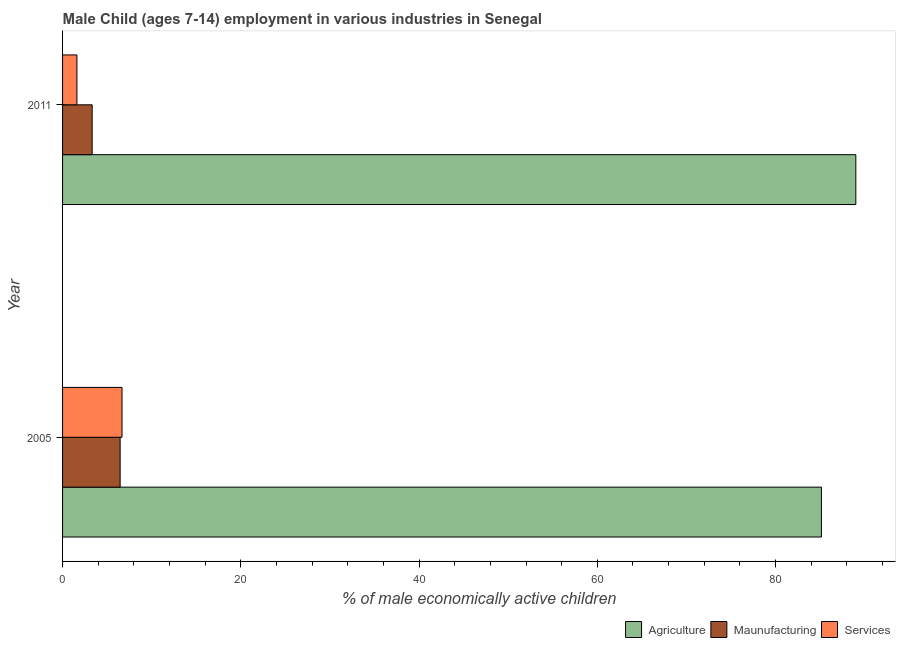What is the percentage of economically active children in services in 2011?
Make the answer very short. 1.61. Across all years, what is the maximum percentage of economically active children in manufacturing?
Offer a terse response. 6.46. Across all years, what is the minimum percentage of economically active children in manufacturing?
Provide a short and direct response. 3.32. In which year was the percentage of economically active children in services minimum?
Offer a terse response. 2011. What is the total percentage of economically active children in manufacturing in the graph?
Keep it short and to the point. 9.78. What is the difference between the percentage of economically active children in agriculture in 2005 and that in 2011?
Ensure brevity in your answer.  -3.86. What is the difference between the percentage of economically active children in agriculture in 2005 and the percentage of economically active children in services in 2011?
Offer a very short reply. 83.54. What is the average percentage of economically active children in manufacturing per year?
Offer a terse response. 4.89. In the year 2005, what is the difference between the percentage of economically active children in agriculture and percentage of economically active children in manufacturing?
Ensure brevity in your answer.  78.69. What is the ratio of the percentage of economically active children in manufacturing in 2005 to that in 2011?
Ensure brevity in your answer.  1.95. Is the percentage of economically active children in services in 2005 less than that in 2011?
Offer a very short reply. No. Is the difference between the percentage of economically active children in services in 2005 and 2011 greater than the difference between the percentage of economically active children in agriculture in 2005 and 2011?
Make the answer very short. Yes. What does the 3rd bar from the top in 2011 represents?
Your answer should be compact. Agriculture. What does the 3rd bar from the bottom in 2005 represents?
Your answer should be very brief. Services. Is it the case that in every year, the sum of the percentage of economically active children in agriculture and percentage of economically active children in manufacturing is greater than the percentage of economically active children in services?
Your response must be concise. Yes. Are all the bars in the graph horizontal?
Keep it short and to the point. Yes. How many years are there in the graph?
Offer a terse response. 2. Are the values on the major ticks of X-axis written in scientific E-notation?
Provide a short and direct response. No. Does the graph contain any zero values?
Your answer should be compact. No. Does the graph contain grids?
Ensure brevity in your answer.  No. How many legend labels are there?
Ensure brevity in your answer.  3. How are the legend labels stacked?
Your response must be concise. Horizontal. What is the title of the graph?
Your response must be concise. Male Child (ages 7-14) employment in various industries in Senegal. Does "Ages 0-14" appear as one of the legend labels in the graph?
Your answer should be compact. No. What is the label or title of the X-axis?
Offer a very short reply. % of male economically active children. What is the label or title of the Y-axis?
Keep it short and to the point. Year. What is the % of male economically active children in Agriculture in 2005?
Offer a terse response. 85.15. What is the % of male economically active children of Maunufacturing in 2005?
Keep it short and to the point. 6.46. What is the % of male economically active children in Services in 2005?
Offer a terse response. 6.67. What is the % of male economically active children in Agriculture in 2011?
Your answer should be compact. 89.01. What is the % of male economically active children in Maunufacturing in 2011?
Your answer should be compact. 3.32. What is the % of male economically active children of Services in 2011?
Make the answer very short. 1.61. Across all years, what is the maximum % of male economically active children in Agriculture?
Ensure brevity in your answer.  89.01. Across all years, what is the maximum % of male economically active children of Maunufacturing?
Give a very brief answer. 6.46. Across all years, what is the maximum % of male economically active children of Services?
Your answer should be very brief. 6.67. Across all years, what is the minimum % of male economically active children in Agriculture?
Provide a short and direct response. 85.15. Across all years, what is the minimum % of male economically active children in Maunufacturing?
Your response must be concise. 3.32. Across all years, what is the minimum % of male economically active children in Services?
Give a very brief answer. 1.61. What is the total % of male economically active children in Agriculture in the graph?
Your answer should be compact. 174.16. What is the total % of male economically active children in Maunufacturing in the graph?
Offer a very short reply. 9.78. What is the total % of male economically active children of Services in the graph?
Provide a succinct answer. 8.28. What is the difference between the % of male economically active children in Agriculture in 2005 and that in 2011?
Provide a succinct answer. -3.86. What is the difference between the % of male economically active children in Maunufacturing in 2005 and that in 2011?
Provide a succinct answer. 3.14. What is the difference between the % of male economically active children in Services in 2005 and that in 2011?
Keep it short and to the point. 5.06. What is the difference between the % of male economically active children of Agriculture in 2005 and the % of male economically active children of Maunufacturing in 2011?
Your answer should be compact. 81.83. What is the difference between the % of male economically active children of Agriculture in 2005 and the % of male economically active children of Services in 2011?
Ensure brevity in your answer.  83.54. What is the difference between the % of male economically active children of Maunufacturing in 2005 and the % of male economically active children of Services in 2011?
Provide a short and direct response. 4.85. What is the average % of male economically active children of Agriculture per year?
Offer a terse response. 87.08. What is the average % of male economically active children of Maunufacturing per year?
Provide a succinct answer. 4.89. What is the average % of male economically active children in Services per year?
Make the answer very short. 4.14. In the year 2005, what is the difference between the % of male economically active children of Agriculture and % of male economically active children of Maunufacturing?
Your answer should be very brief. 78.69. In the year 2005, what is the difference between the % of male economically active children in Agriculture and % of male economically active children in Services?
Your response must be concise. 78.48. In the year 2005, what is the difference between the % of male economically active children in Maunufacturing and % of male economically active children in Services?
Ensure brevity in your answer.  -0.21. In the year 2011, what is the difference between the % of male economically active children of Agriculture and % of male economically active children of Maunufacturing?
Ensure brevity in your answer.  85.69. In the year 2011, what is the difference between the % of male economically active children of Agriculture and % of male economically active children of Services?
Your answer should be compact. 87.4. In the year 2011, what is the difference between the % of male economically active children in Maunufacturing and % of male economically active children in Services?
Offer a very short reply. 1.71. What is the ratio of the % of male economically active children in Agriculture in 2005 to that in 2011?
Your response must be concise. 0.96. What is the ratio of the % of male economically active children in Maunufacturing in 2005 to that in 2011?
Your answer should be compact. 1.95. What is the ratio of the % of male economically active children of Services in 2005 to that in 2011?
Offer a very short reply. 4.14. What is the difference between the highest and the second highest % of male economically active children in Agriculture?
Offer a very short reply. 3.86. What is the difference between the highest and the second highest % of male economically active children of Maunufacturing?
Offer a terse response. 3.14. What is the difference between the highest and the second highest % of male economically active children of Services?
Offer a very short reply. 5.06. What is the difference between the highest and the lowest % of male economically active children of Agriculture?
Offer a terse response. 3.86. What is the difference between the highest and the lowest % of male economically active children in Maunufacturing?
Make the answer very short. 3.14. What is the difference between the highest and the lowest % of male economically active children in Services?
Give a very brief answer. 5.06. 